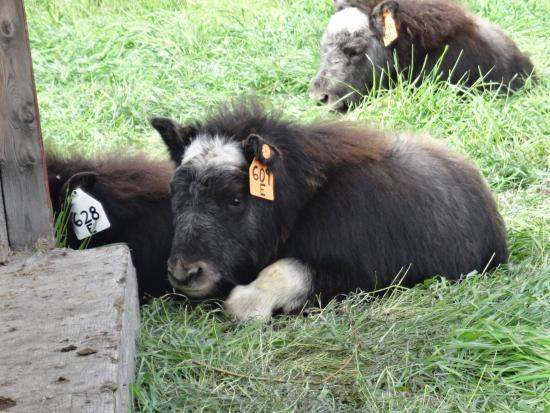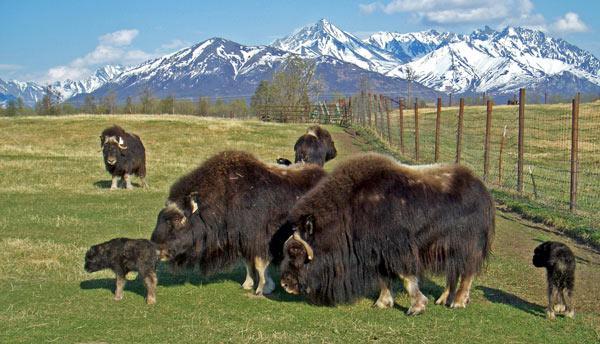The first image is the image on the left, the second image is the image on the right. For the images shown, is this caption "A single bull is walking past a metal fence in the image on the right." true? Answer yes or no. No. The first image is the image on the left, the second image is the image on the right. Assess this claim about the two images: "An image shows at least one shaggy buffalo standing in a field in front of blue mountains, with fence posts on the right behind the animal.". Correct or not? Answer yes or no. Yes. 